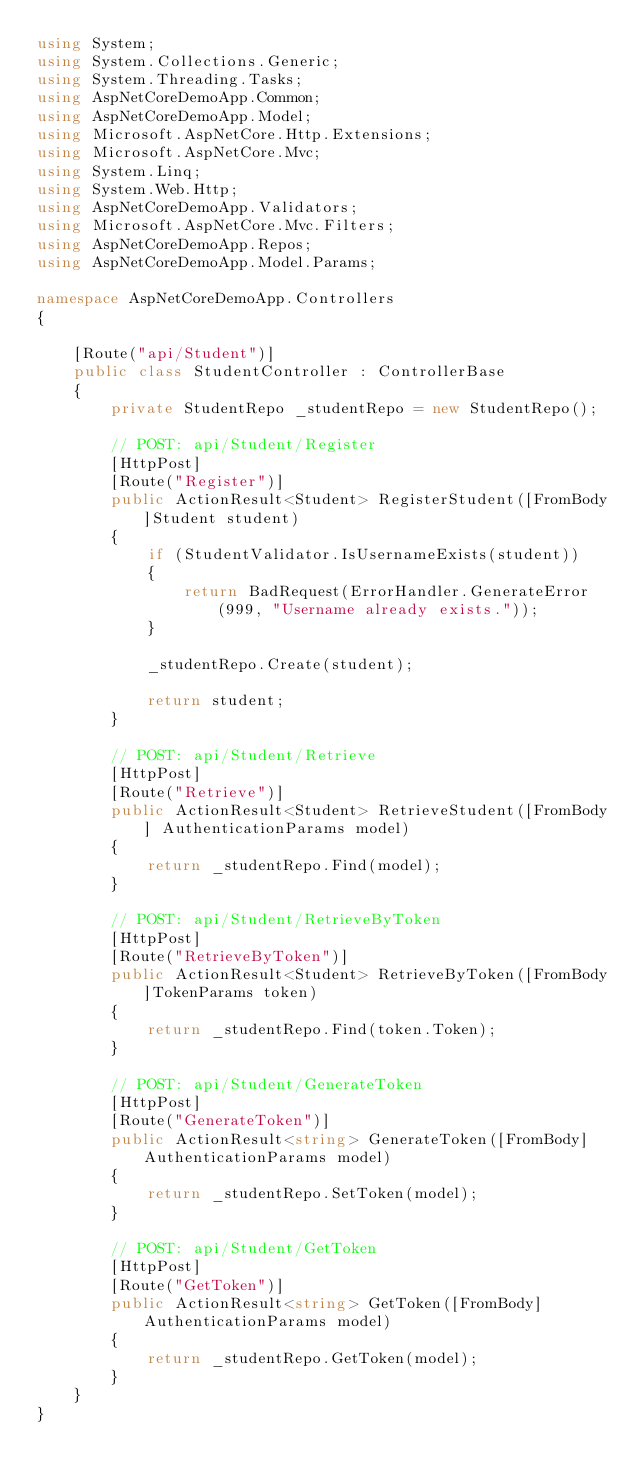Convert code to text. <code><loc_0><loc_0><loc_500><loc_500><_C#_>using System;
using System.Collections.Generic;
using System.Threading.Tasks;
using AspNetCoreDemoApp.Common;
using AspNetCoreDemoApp.Model;
using Microsoft.AspNetCore.Http.Extensions;
using Microsoft.AspNetCore.Mvc;
using System.Linq;
using System.Web.Http;
using AspNetCoreDemoApp.Validators;
using Microsoft.AspNetCore.Mvc.Filters;
using AspNetCoreDemoApp.Repos;
using AspNetCoreDemoApp.Model.Params;

namespace AspNetCoreDemoApp.Controllers
{

    [Route("api/Student")]
    public class StudentController : ControllerBase
    {
        private StudentRepo _studentRepo = new StudentRepo();

        // POST: api/Student/Register
        [HttpPost]
        [Route("Register")]
        public ActionResult<Student> RegisterStudent([FromBody]Student student)
        {
            if (StudentValidator.IsUsernameExists(student))
            {
                return BadRequest(ErrorHandler.GenerateError(999, "Username already exists."));
            }

            _studentRepo.Create(student);

            return student;
        }

        // POST: api/Student/Retrieve
        [HttpPost]
        [Route("Retrieve")]
        public ActionResult<Student> RetrieveStudent([FromBody] AuthenticationParams model)
        {
            return _studentRepo.Find(model);
        }

        // POST: api/Student/RetrieveByToken
        [HttpPost]
        [Route("RetrieveByToken")]
        public ActionResult<Student> RetrieveByToken([FromBody]TokenParams token)
        {
            return _studentRepo.Find(token.Token);
        }

        // POST: api/Student/GenerateToken
        [HttpPost]
        [Route("GenerateToken")]
        public ActionResult<string> GenerateToken([FromBody]AuthenticationParams model)
        {
            return _studentRepo.SetToken(model);
        }

        // POST: api/Student/GetToken
        [HttpPost]
        [Route("GetToken")]
        public ActionResult<string> GetToken([FromBody]AuthenticationParams model)
        {
            return _studentRepo.GetToken(model);
        }
    }
}</code> 